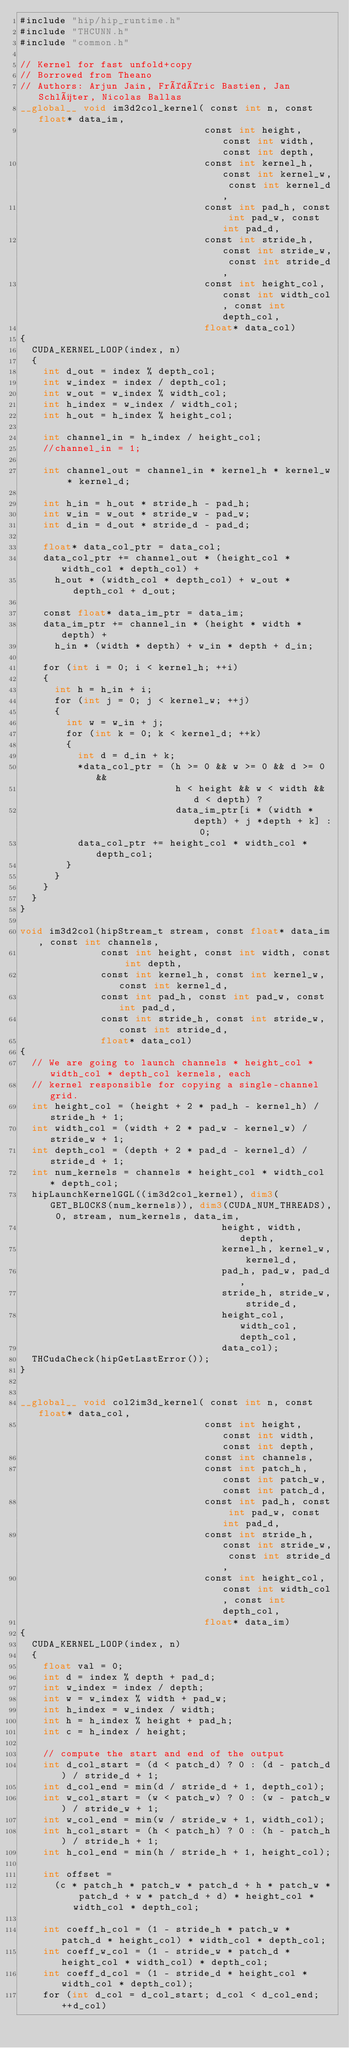Convert code to text. <code><loc_0><loc_0><loc_500><loc_500><_Cuda_>#include "hip/hip_runtime.h"
#include "THCUNN.h"
#include "common.h"

// Kernel for fast unfold+copy
// Borrowed from Theano
// Authors: Arjun Jain, Frédéric Bastien, Jan Schlüter, Nicolas Ballas
__global__ void im3d2col_kernel( const int n, const float* data_im,
                                const int height, const int width, const int depth,
                                const int kernel_h, const int kernel_w, const int kernel_d,
                                const int pad_h, const int pad_w, const int pad_d,
                                const int stride_h, const int stride_w, const int stride_d,
                                const int height_col, const int width_col, const int depth_col,
                                float* data_col)
{
  CUDA_KERNEL_LOOP(index, n)
  {
    int d_out = index % depth_col;
    int w_index = index / depth_col;
    int w_out = w_index % width_col;
    int h_index = w_index / width_col;
    int h_out = h_index % height_col;

    int channel_in = h_index / height_col;
    //channel_in = 1;

    int channel_out = channel_in * kernel_h * kernel_w * kernel_d;

    int h_in = h_out * stride_h - pad_h;
    int w_in = w_out * stride_w - pad_w;
    int d_in = d_out * stride_d - pad_d;

    float* data_col_ptr = data_col;
    data_col_ptr += channel_out * (height_col * width_col * depth_col) +
      h_out * (width_col * depth_col) + w_out * depth_col + d_out;

    const float* data_im_ptr = data_im;
    data_im_ptr += channel_in * (height * width * depth) +
      h_in * (width * depth) + w_in * depth + d_in;

    for (int i = 0; i < kernel_h; ++i)
    {
      int h = h_in + i;
      for (int j = 0; j < kernel_w; ++j)
      {
        int w = w_in + j;
        for (int k = 0; k < kernel_d; ++k)
        {
          int d = d_in + k;
          *data_col_ptr = (h >= 0 && w >= 0 && d >= 0 &&
                           h < height && w < width && d < depth) ?
                           data_im_ptr[i * (width * depth) + j *depth + k] : 0;
          data_col_ptr += height_col * width_col * depth_col;
        }
      }
    }
  }
}

void im3d2col(hipStream_t stream, const float* data_im, const int channels,
              const int height, const int width, const int depth,
              const int kernel_h, const int kernel_w, const int kernel_d,
              const int pad_h, const int pad_w, const int pad_d,
              const int stride_h, const int stride_w, const int stride_d,
              float* data_col)
{
  // We are going to launch channels * height_col * width_col * depth_col kernels, each
  // kernel responsible for copying a single-channel grid.
  int height_col = (height + 2 * pad_h - kernel_h) / stride_h + 1;
  int width_col = (width + 2 * pad_w - kernel_w) / stride_w + 1;
  int depth_col = (depth + 2 * pad_d - kernel_d) / stride_d + 1;
  int num_kernels = channels * height_col * width_col * depth_col;
  hipLaunchKernelGGL((im3d2col_kernel), dim3(GET_BLOCKS(num_kernels)), dim3(CUDA_NUM_THREADS), 0, stream, num_kernels, data_im,
                                   height, width, depth,
                                   kernel_h, kernel_w, kernel_d,
                                   pad_h, pad_w, pad_d,
                                   stride_h, stride_w, stride_d,
                                   height_col, width_col, depth_col,
                                   data_col);
  THCudaCheck(hipGetLastError());
}


__global__ void col2im3d_kernel( const int n, const float* data_col,
                                const int height, const int width, const int depth,
                                const int channels,
                                const int patch_h, const int patch_w, const int patch_d,
                                const int pad_h, const int pad_w, const int pad_d,
                                const int stride_h, const int stride_w, const int stride_d,
                                const int height_col, const int width_col, const int depth_col,
                                float* data_im)
{
  CUDA_KERNEL_LOOP(index, n)
  {
    float val = 0;
    int d = index % depth + pad_d;
    int w_index = index / depth;
    int w = w_index % width + pad_w;
    int h_index = w_index / width;
    int h = h_index % height + pad_h;
    int c = h_index / height;

    // compute the start and end of the output
    int d_col_start = (d < patch_d) ? 0 : (d - patch_d) / stride_d + 1;
    int d_col_end = min(d / stride_d + 1, depth_col);
    int w_col_start = (w < patch_w) ? 0 : (w - patch_w) / stride_w + 1;
    int w_col_end = min(w / stride_w + 1, width_col);
    int h_col_start = (h < patch_h) ? 0 : (h - patch_h) / stride_h + 1;
    int h_col_end = min(h / stride_h + 1, height_col);

    int offset =
      (c * patch_h * patch_w * patch_d + h * patch_w * patch_d + w * patch_d + d) * height_col * width_col * depth_col;

    int coeff_h_col = (1 - stride_h * patch_w * patch_d * height_col) * width_col * depth_col;
    int coeff_w_col = (1 - stride_w * patch_d * height_col * width_col) * depth_col;
    int coeff_d_col = (1 - stride_d * height_col * width_col * depth_col);
    for (int d_col = d_col_start; d_col < d_col_end; ++d_col)</code> 